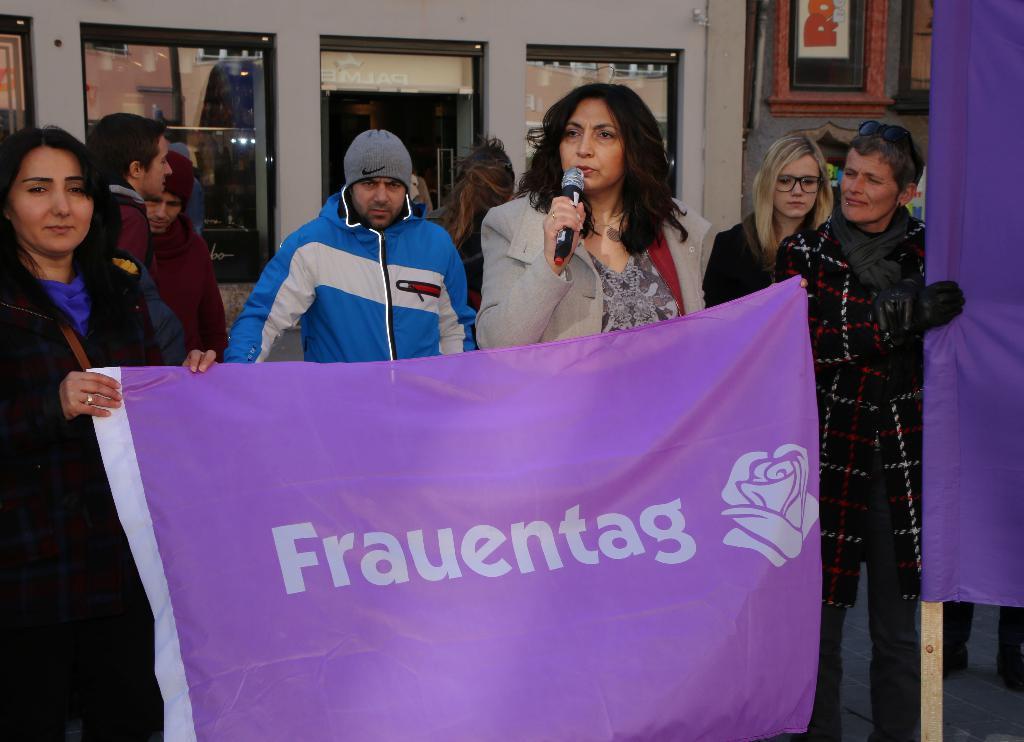Could you give a brief overview of what you see in this image? In the middle a woman is talking on the microphone, here few persons are holding the banner, it is in purple color. Behind them it looks like a store. 